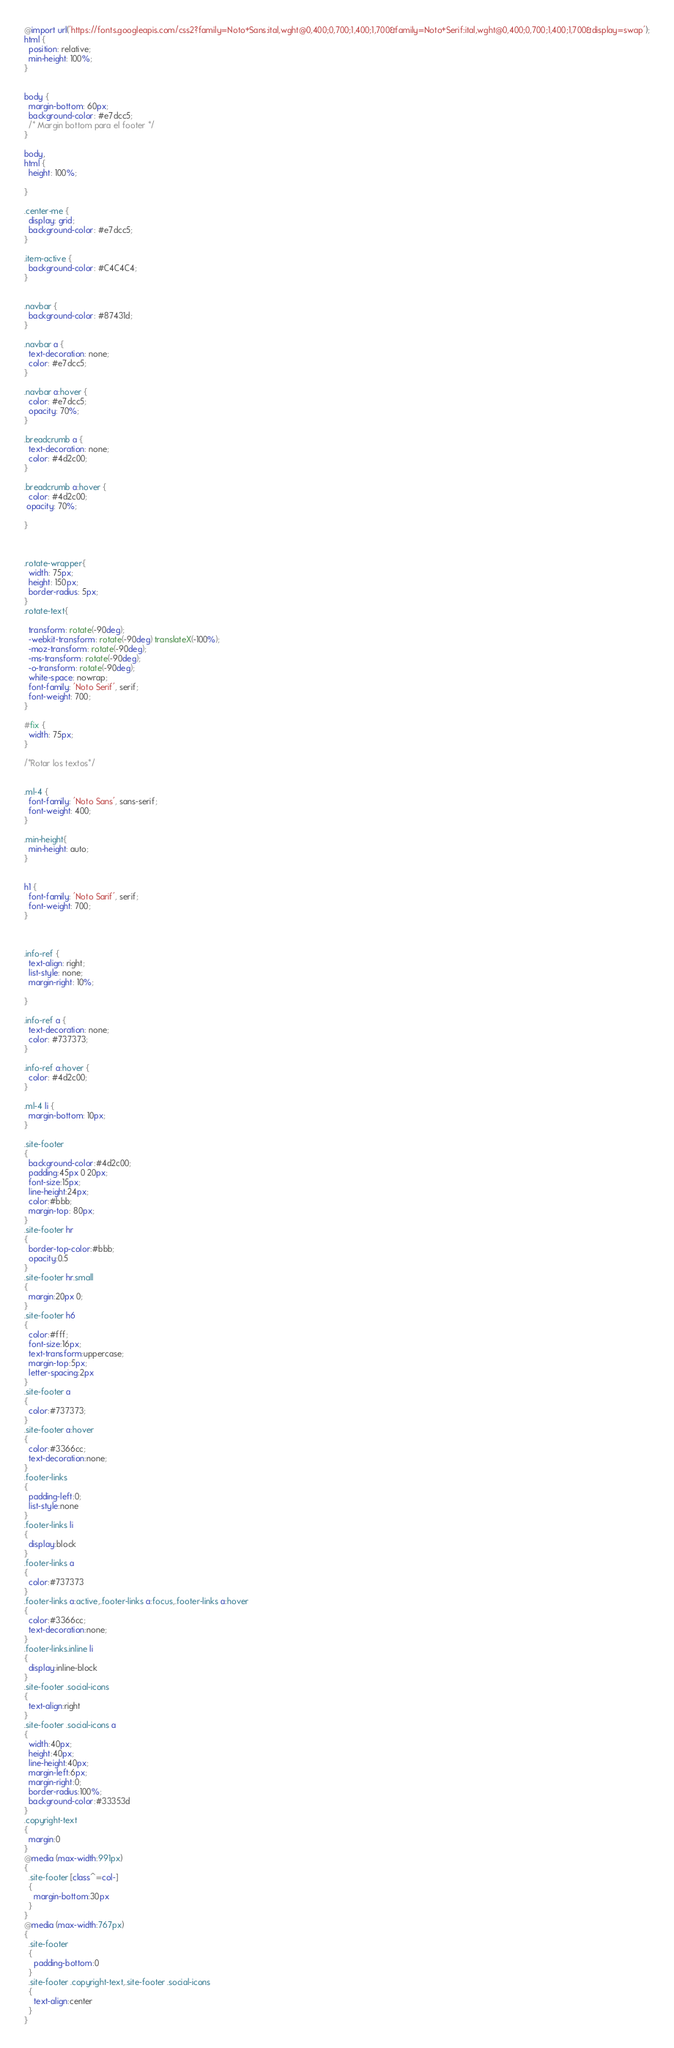Convert code to text. <code><loc_0><loc_0><loc_500><loc_500><_CSS_>@import url('https://fonts.googleapis.com/css2?family=Noto+Sans:ital,wght@0,400;0,700;1,400;1,700&family=Noto+Serif:ital,wght@0,400;0,700;1,400;1,700&display=swap');
html {
  position: relative;
  min-height: 100%;
}


body {
  margin-bottom: 60px;
  background-color: #e7dcc5;
  /* Margin bottom para el footer */
}

body,
html {
  height: 100%;

}

.center-me {
  display: grid;
  background-color: #e7dcc5;
}

.item-active {
  background-color: #C4C4C4;
}


.navbar {
  background-color: #87431d;
}

.navbar a {
  text-decoration: none;
  color: #e7dcc5;
}

.navbar a:hover {
  color: #e7dcc5;
  opacity: 70%;
}

.breadcrumb a {
  text-decoration: none;
  color: #4d2c00;
}

.breadcrumb a:hover {
  color: #4d2c00;
 opacity: 70%;

}



.rotate-wrapper{
  width: 75px;
  height: 150px;
  border-radius: 5px;
}
.rotate-text{

  transform: rotate(-90deg);
  -webkit-transform: rotate(-90deg) translateX(-100%);
  -moz-transform: rotate(-90deg);
  -ms-transform: rotate(-90deg);
  -o-transform: rotate(-90deg);
  white-space: nowrap;
  font-family: 'Noto Serif', serif;
  font-weight: 700;
}

#fix {
  width: 75px;
}

/*Rotar los textos*/


.ml-4 {
  font-family: 'Noto Sans', sans-serif;
  font-weight: 400;
}

.min-height{
  min-height: auto;
}


h1 {
  font-family: 'Noto Sarif', serif;
  font-weight: 700;
}



.info-ref {
  text-align: right;
  list-style: none;
  margin-right: 10%;

}

.info-ref a {
  text-decoration: none;
  color: #737373;
}

.info-ref a:hover {
  color: #4d2c00;
}

.ml-4 li {
  margin-bottom: 10px;
}

.site-footer
{
  background-color:#4d2c00;
  padding:45px 0 20px;
  font-size:15px;
  line-height:24px;
  color:#bbb;
  margin-top: 80px;
}
.site-footer hr
{
  border-top-color:#bbb;
  opacity:0.5
}
.site-footer hr.small
{
  margin:20px 0;
}
.site-footer h6
{
  color:#fff;
  font-size:16px;
  text-transform:uppercase;
  margin-top:5px;
  letter-spacing:2px
}
.site-footer a
{
  color:#737373;
}
.site-footer a:hover
{
  color:#3366cc;
  text-decoration:none;
}
.footer-links
{
  padding-left:0;
  list-style:none
}
.footer-links li
{
  display:block
}
.footer-links a
{
  color:#737373
}
.footer-links a:active,.footer-links a:focus,.footer-links a:hover
{
  color:#3366cc;
  text-decoration:none;
}
.footer-links.inline li
{
  display:inline-block
}
.site-footer .social-icons
{
  text-align:right
}
.site-footer .social-icons a
{
  width:40px;
  height:40px;
  line-height:40px;
  margin-left:6px;
  margin-right:0;
  border-radius:100%;
  background-color:#33353d
}
.copyright-text
{
  margin:0
}
@media (max-width:991px)
{
  .site-footer [class^=col-]
  {
    margin-bottom:30px
  }
}
@media (max-width:767px)
{
  .site-footer
  {
    padding-bottom:0
  }
  .site-footer .copyright-text,.site-footer .social-icons
  {
    text-align:center
  }
}
</code> 